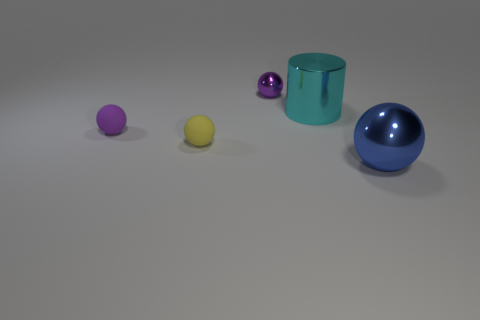Is there a purple object of the same size as the metallic cylinder?
Offer a terse response. No. There is a cylinder; is it the same color as the shiny thing behind the cyan metal object?
Offer a very short reply. No. What number of cyan metallic things are to the left of the metal sphere on the left side of the blue object?
Your response must be concise. 0. What color is the shiny cylinder that is on the right side of the metallic object left of the large cylinder?
Provide a short and direct response. Cyan. There is a thing that is both right of the purple metal sphere and on the left side of the blue metallic sphere; what material is it made of?
Keep it short and to the point. Metal. Is there a purple rubber object of the same shape as the cyan shiny object?
Your response must be concise. No. Does the shiny object in front of the small yellow thing have the same shape as the tiny yellow object?
Give a very brief answer. Yes. What number of objects are in front of the cyan thing and behind the blue shiny thing?
Your answer should be very brief. 2. There is a tiny thing to the right of the yellow matte object; what is its shape?
Offer a very short reply. Sphere. What number of small spheres are the same material as the large cyan object?
Make the answer very short. 1. 